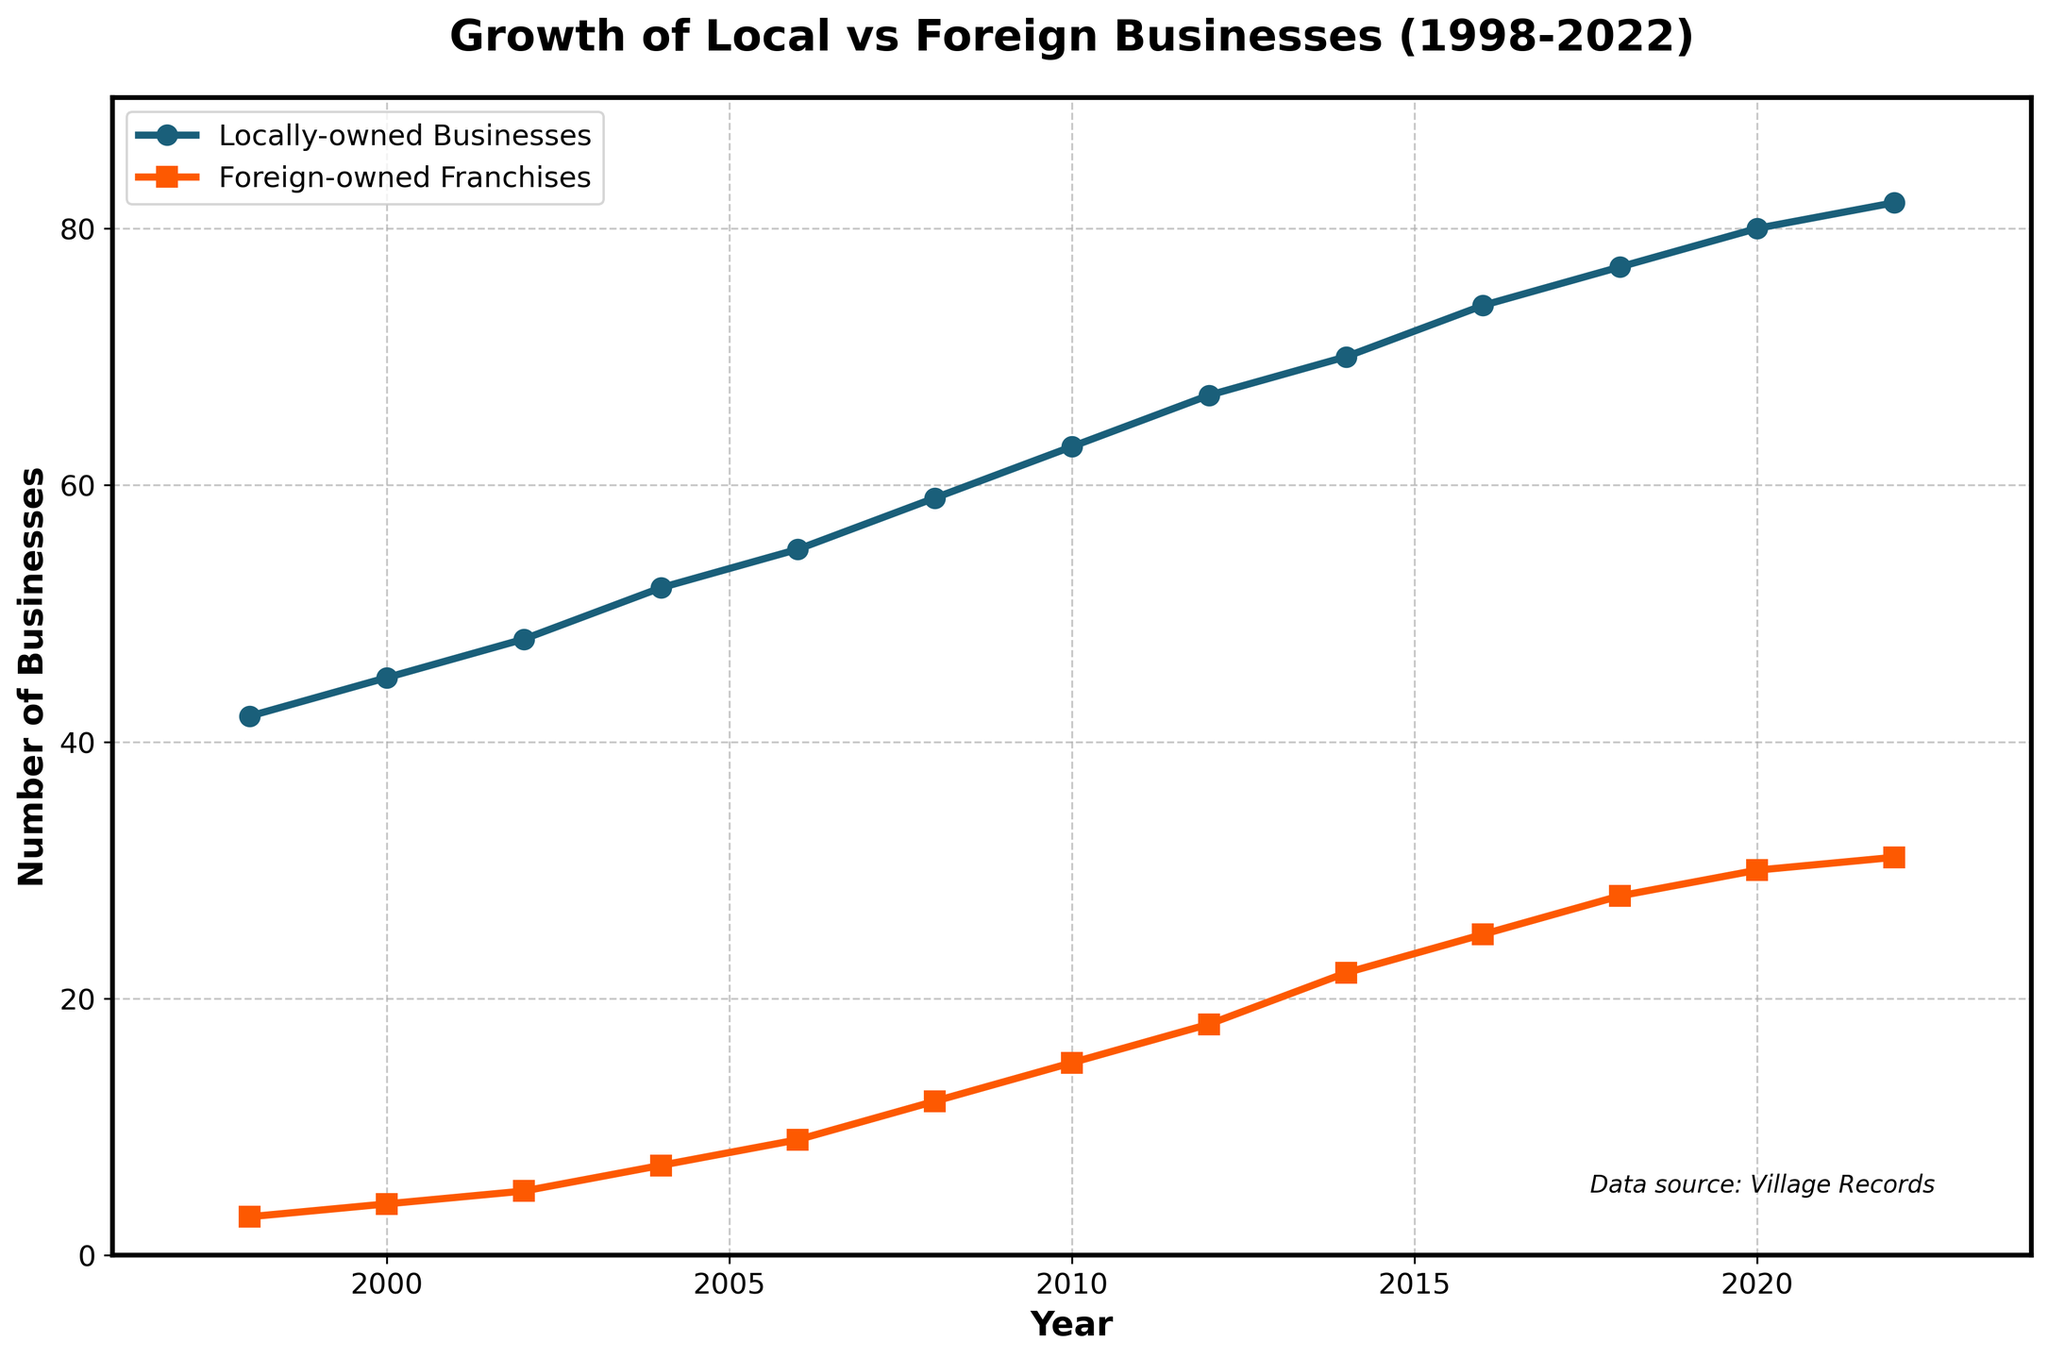What's the total number of locally-owned businesses in the village by the end of 2022? To find the total number of locally-owned businesses by the end of 2022, look at the y-value corresponding to the year 2022 on the blue line representing locally-owned businesses.
Answer: 82 How did the number of foreign-owned franchises change from 2016 to 2022? Check the y-values for foreign-owned franchises (orange line) for the years 2016 and 2022. The number in 2016 is 25 and in 2022 it is 31. Subtract the former from the latter to find the change. 31 - 25 = 6
Answer: Increased by 6 Which year did the locally-owned businesses surpass the 60 mark? Find the point on the blue line where it crosses the y-value of 60. This occurs between 2008 and 2010. Checking the exact value for 2010 shows it is 63.
Answer: 2010 In which year was the gap between locally-owned businesses and foreign-owned franchises the widest? Calculate the difference between the y-values of locally-owned businesses and foreign-owned franchises for each year. Identify the year with the largest difference. The gap is widest in the initial years, specifically in 1998, with 42 - 3 = 39.
Answer: 1998 Compare the growth trends of locally-owned businesses and foreign-owned franchises. Which shows a steeper increase? To determine which has a steeper increase, we examine the slopes of both lines. The locally-owned businesses have a smooth ascending slope, while the foreign-owned franchises have a more gradual but steady slope. The foreign-owned franchises show the steeper relative increase due to the lower initial values and relatively higher growth rate percentage-wise.
Answer: Foreign-owned franchises By how much did the number of locally-owned businesses exceed foreign-owned franchises in 2022? Compare the y-values for both categories in 2022: locally-owned businesses (82) and foreign-owned franchises (31). Subtract the smaller number from the larger: 82 - 31 = 51.
Answer: By 51 businesses How many years did it take for the number of foreign-owned franchises to reach double digits? Observe the orange line and find the first year where the y-value is 10 or more. This happens in 2008 when it reaches 12. So, from 1998, it took 10 years (2008 - 1998).
Answer: 10 years What is the average annual growth rate of locally-owned businesses from 1998 to 2022? First, calculate the total growth of locally-owned businesses from 1998 (42) to 2022 (82). The total growth is 82 - 42 = 40. Then, divide this by the number of years (2022 - 1998 = 24 years). The average annual growth rate is 40 / 24 ≈ 1.67 businesses per year.
Answer: 1.67 businesses per year 